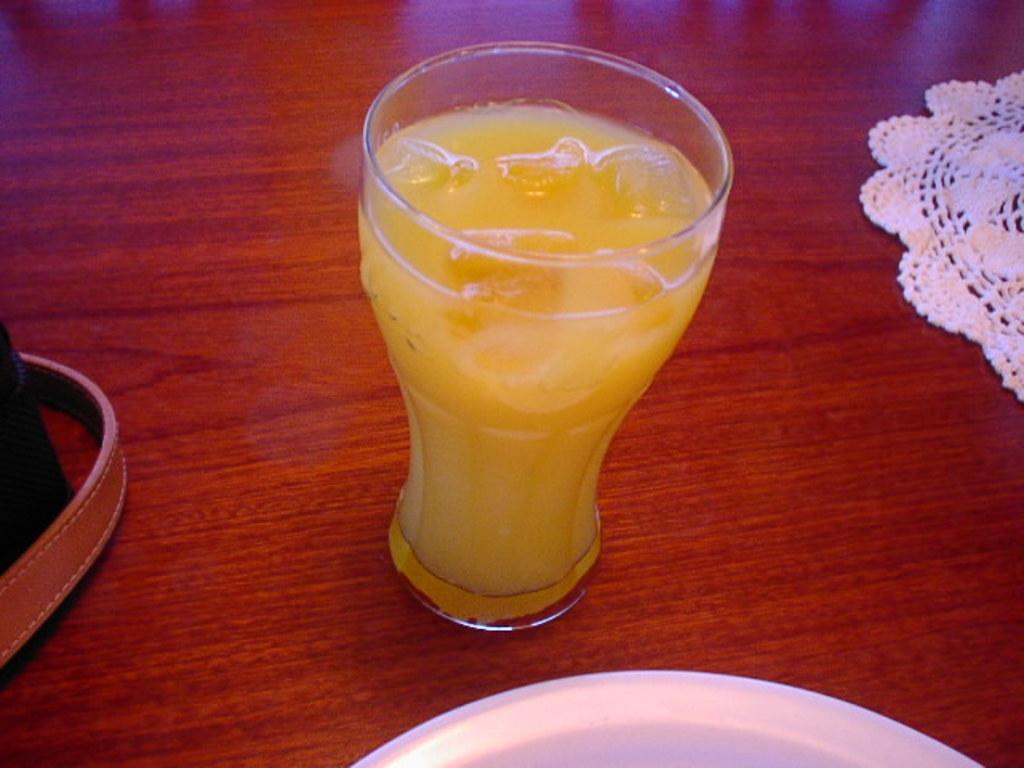In one or two sentences, can you explain what this image depicts? In this image, I think this is a glass of juice with the ice cubes in it. This looks like a wooden table. I can see a cloth, plate and a glass are placed on the table. 